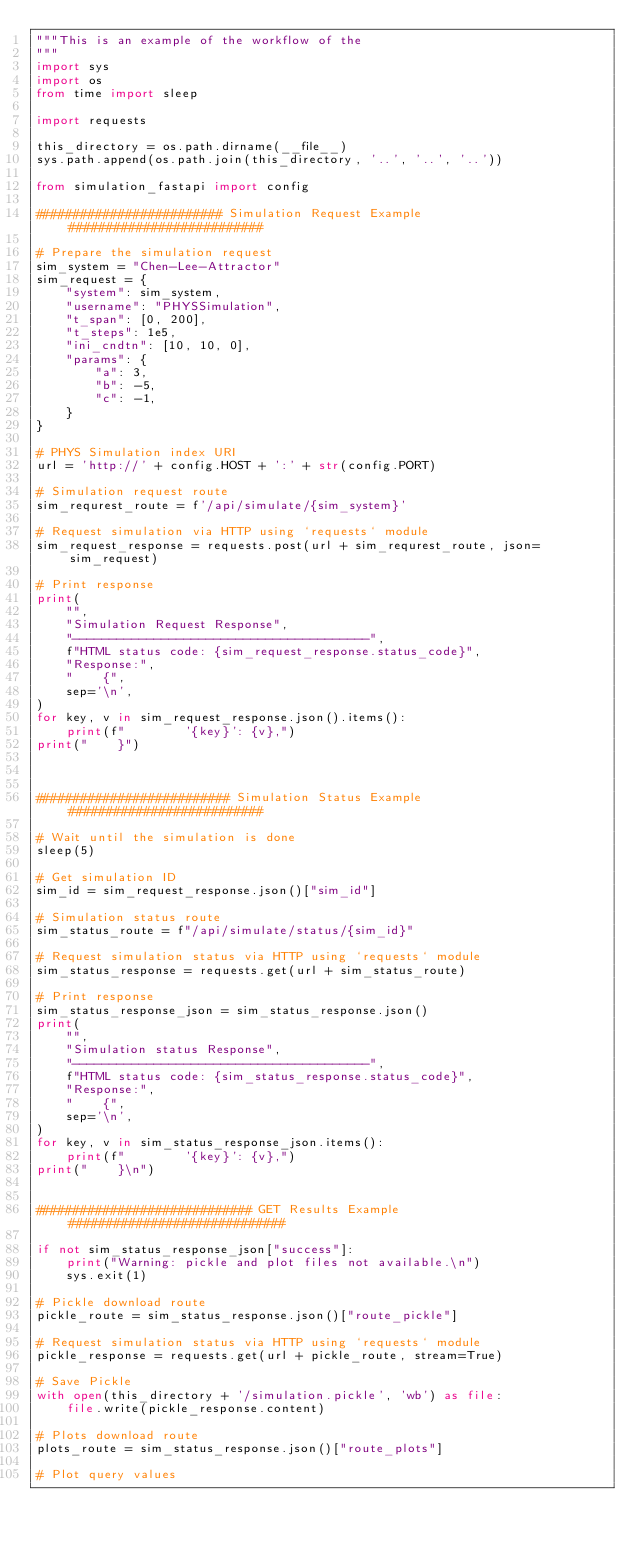<code> <loc_0><loc_0><loc_500><loc_500><_Python_>"""This is an example of the workflow of the 
"""
import sys
import os
from time import sleep

import requests

this_directory = os.path.dirname(__file__)
sys.path.append(os.path.join(this_directory, '..', '..', '..'))

from simulation_fastapi import config

######################### Simulation Request Example ##########################

# Prepare the simulation request
sim_system = "Chen-Lee-Attractor"
sim_request = {
    "system": sim_system,
    "username": "PHYSSimulation",
    "t_span": [0, 200],
    "t_steps": 1e5,
    "ini_cndtn": [10, 10, 0],
    "params": {
        "a": 3,
        "b": -5,
        "c": -1,
    }
}

# PHYS Simulation index URI
url = 'http://' + config.HOST + ':' + str(config.PORT)

# Simulation request route
sim_requrest_route = f'/api/simulate/{sim_system}'

# Request simulation via HTTP using `requests` module
sim_request_response = requests.post(url + sim_requrest_route, json=sim_request)

# Print response
print(
    "",
    "Simulation Request Response",
    "----------------------------------------",
    f"HTML status code: {sim_request_response.status_code}",
    "Response:",
    "    {",
    sep='\n',
)
for key, v in sim_request_response.json().items():
    print(f"        '{key}': {v},")
print("    }")



########################## Simulation Status Example ##########################

# Wait until the simulation is done
sleep(5)

# Get simulation ID
sim_id = sim_request_response.json()["sim_id"]

# Simulation status route
sim_status_route = f"/api/simulate/status/{sim_id}"

# Request simulation status via HTTP using `requests` module
sim_status_response = requests.get(url + sim_status_route)

# Print response
sim_status_response_json = sim_status_response.json()
print(
    "",
    "Simulation status Response",
    "----------------------------------------",
    f"HTML status code: {sim_status_response.status_code}",
    "Response:",
    "    {",
    sep='\n',
)
for key, v in sim_status_response_json.items():
    print(f"        '{key}': {v},")
print("    }\n")


############################# GET Results Example #############################

if not sim_status_response_json["success"]:
    print("Warning: pickle and plot files not available.\n")
    sys.exit(1)

# Pickle download route
pickle_route = sim_status_response.json()["route_pickle"]

# Request simulation status via HTTP using `requests` module
pickle_response = requests.get(url + pickle_route, stream=True)

# Save Pickle
with open(this_directory + '/simulation.pickle', 'wb') as file:
    file.write(pickle_response.content)

# Plots download route
plots_route = sim_status_response.json()["route_plots"]

# Plot query values</code> 